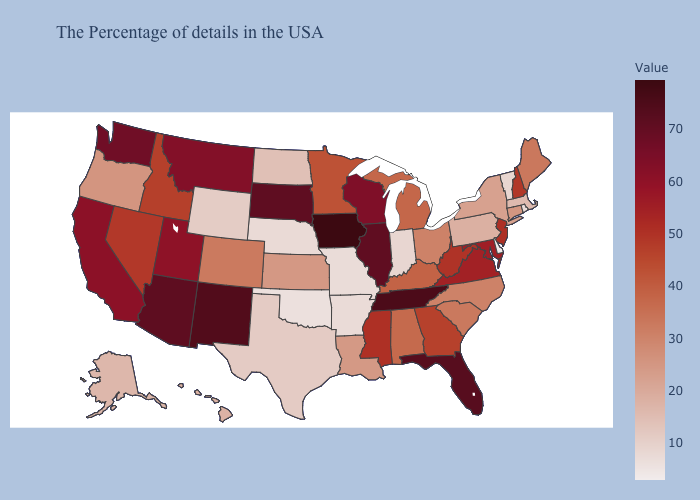Does the map have missing data?
Keep it brief. No. Does Maine have the lowest value in the USA?
Write a very short answer. No. Which states have the lowest value in the MidWest?
Give a very brief answer. Missouri. 